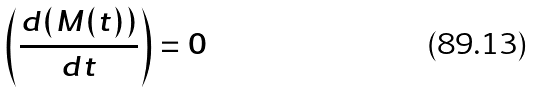<formula> <loc_0><loc_0><loc_500><loc_500>\left ( \frac { d ( M ( t ) ) } { d t } \right ) = 0</formula> 